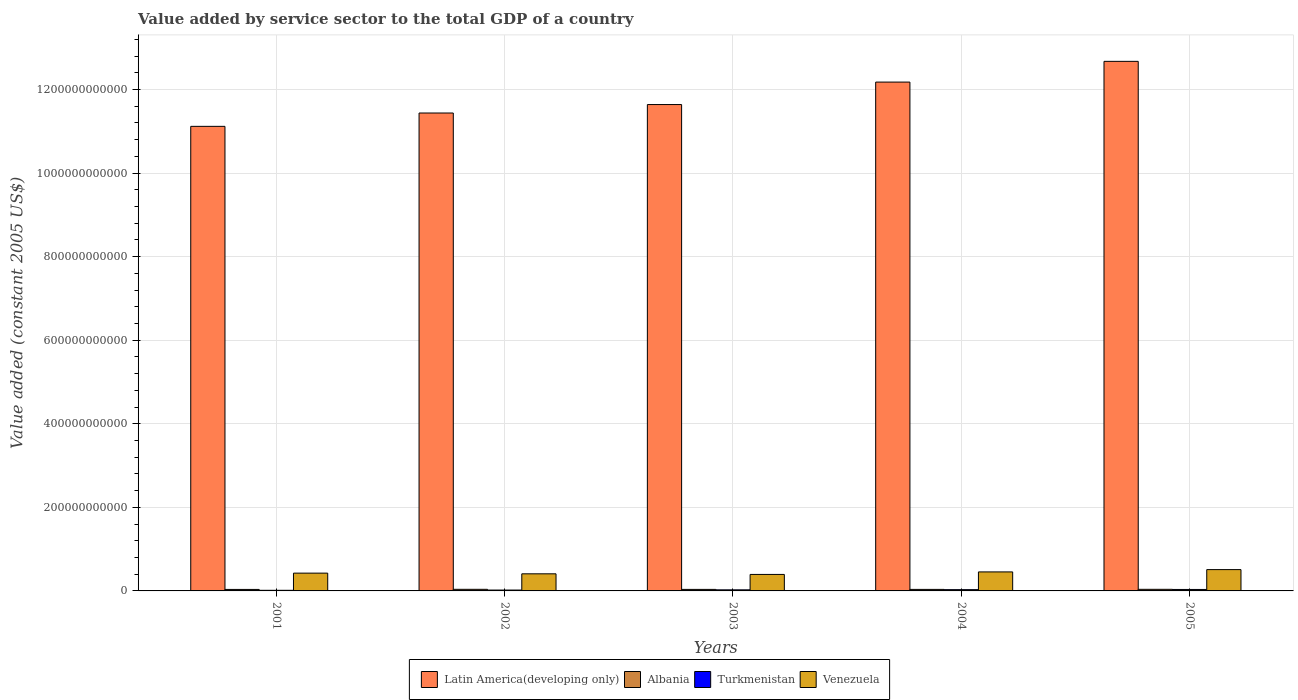How many different coloured bars are there?
Ensure brevity in your answer.  4. How many groups of bars are there?
Offer a very short reply. 5. How many bars are there on the 5th tick from the right?
Your response must be concise. 4. What is the label of the 5th group of bars from the left?
Your answer should be very brief. 2005. What is the value added by service sector in Venezuela in 2004?
Your answer should be very brief. 4.55e+1. Across all years, what is the maximum value added by service sector in Turkmenistan?
Your response must be concise. 3.48e+09. Across all years, what is the minimum value added by service sector in Turkmenistan?
Your response must be concise. 1.47e+09. In which year was the value added by service sector in Latin America(developing only) maximum?
Your response must be concise. 2005. In which year was the value added by service sector in Turkmenistan minimum?
Give a very brief answer. 2001. What is the total value added by service sector in Latin America(developing only) in the graph?
Provide a short and direct response. 5.91e+12. What is the difference between the value added by service sector in Turkmenistan in 2003 and that in 2005?
Your answer should be very brief. -8.97e+08. What is the difference between the value added by service sector in Albania in 2005 and the value added by service sector in Latin America(developing only) in 2001?
Keep it short and to the point. -1.11e+12. What is the average value added by service sector in Latin America(developing only) per year?
Offer a terse response. 1.18e+12. In the year 2004, what is the difference between the value added by service sector in Turkmenistan and value added by service sector in Latin America(developing only)?
Ensure brevity in your answer.  -1.21e+12. What is the ratio of the value added by service sector in Albania in 2001 to that in 2005?
Make the answer very short. 0.94. Is the value added by service sector in Latin America(developing only) in 2001 less than that in 2005?
Your answer should be very brief. Yes. What is the difference between the highest and the second highest value added by service sector in Albania?
Your response must be concise. 7.24e+05. What is the difference between the highest and the lowest value added by service sector in Albania?
Ensure brevity in your answer.  2.42e+08. In how many years, is the value added by service sector in Venezuela greater than the average value added by service sector in Venezuela taken over all years?
Keep it short and to the point. 2. Is it the case that in every year, the sum of the value added by service sector in Turkmenistan and value added by service sector in Venezuela is greater than the sum of value added by service sector in Latin America(developing only) and value added by service sector in Albania?
Your response must be concise. No. What does the 4th bar from the left in 2005 represents?
Ensure brevity in your answer.  Venezuela. What does the 4th bar from the right in 2005 represents?
Make the answer very short. Latin America(developing only). Is it the case that in every year, the sum of the value added by service sector in Latin America(developing only) and value added by service sector in Albania is greater than the value added by service sector in Venezuela?
Make the answer very short. Yes. How many bars are there?
Provide a succinct answer. 20. How many years are there in the graph?
Ensure brevity in your answer.  5. What is the difference between two consecutive major ticks on the Y-axis?
Your response must be concise. 2.00e+11. Are the values on the major ticks of Y-axis written in scientific E-notation?
Keep it short and to the point. No. Does the graph contain any zero values?
Offer a very short reply. No. Where does the legend appear in the graph?
Offer a very short reply. Bottom center. How many legend labels are there?
Provide a short and direct response. 4. What is the title of the graph?
Give a very brief answer. Value added by service sector to the total GDP of a country. What is the label or title of the X-axis?
Give a very brief answer. Years. What is the label or title of the Y-axis?
Give a very brief answer. Value added (constant 2005 US$). What is the Value added (constant 2005 US$) of Latin America(developing only) in 2001?
Keep it short and to the point. 1.11e+12. What is the Value added (constant 2005 US$) in Albania in 2001?
Ensure brevity in your answer.  3.59e+09. What is the Value added (constant 2005 US$) in Turkmenistan in 2001?
Give a very brief answer. 1.47e+09. What is the Value added (constant 2005 US$) in Venezuela in 2001?
Your response must be concise. 4.26e+1. What is the Value added (constant 2005 US$) of Latin America(developing only) in 2002?
Provide a short and direct response. 1.14e+12. What is the Value added (constant 2005 US$) in Albania in 2002?
Your answer should be very brief. 3.83e+09. What is the Value added (constant 2005 US$) in Turkmenistan in 2002?
Your response must be concise. 2.07e+09. What is the Value added (constant 2005 US$) of Venezuela in 2002?
Give a very brief answer. 4.09e+1. What is the Value added (constant 2005 US$) in Latin America(developing only) in 2003?
Make the answer very short. 1.16e+12. What is the Value added (constant 2005 US$) in Albania in 2003?
Ensure brevity in your answer.  3.63e+09. What is the Value added (constant 2005 US$) in Turkmenistan in 2003?
Your answer should be very brief. 2.58e+09. What is the Value added (constant 2005 US$) of Venezuela in 2003?
Your response must be concise. 3.95e+1. What is the Value added (constant 2005 US$) of Latin America(developing only) in 2004?
Offer a terse response. 1.22e+12. What is the Value added (constant 2005 US$) of Albania in 2004?
Provide a short and direct response. 3.64e+09. What is the Value added (constant 2005 US$) in Turkmenistan in 2004?
Make the answer very short. 3.06e+09. What is the Value added (constant 2005 US$) of Venezuela in 2004?
Ensure brevity in your answer.  4.55e+1. What is the Value added (constant 2005 US$) of Latin America(developing only) in 2005?
Provide a succinct answer. 1.27e+12. What is the Value added (constant 2005 US$) of Albania in 2005?
Offer a terse response. 3.83e+09. What is the Value added (constant 2005 US$) in Turkmenistan in 2005?
Your answer should be very brief. 3.48e+09. What is the Value added (constant 2005 US$) in Venezuela in 2005?
Offer a terse response. 5.10e+1. Across all years, what is the maximum Value added (constant 2005 US$) in Latin America(developing only)?
Your response must be concise. 1.27e+12. Across all years, what is the maximum Value added (constant 2005 US$) in Albania?
Give a very brief answer. 3.83e+09. Across all years, what is the maximum Value added (constant 2005 US$) of Turkmenistan?
Offer a very short reply. 3.48e+09. Across all years, what is the maximum Value added (constant 2005 US$) of Venezuela?
Provide a succinct answer. 5.10e+1. Across all years, what is the minimum Value added (constant 2005 US$) of Latin America(developing only)?
Your response must be concise. 1.11e+12. Across all years, what is the minimum Value added (constant 2005 US$) in Albania?
Give a very brief answer. 3.59e+09. Across all years, what is the minimum Value added (constant 2005 US$) of Turkmenistan?
Make the answer very short. 1.47e+09. Across all years, what is the minimum Value added (constant 2005 US$) of Venezuela?
Provide a short and direct response. 3.95e+1. What is the total Value added (constant 2005 US$) in Latin America(developing only) in the graph?
Provide a short and direct response. 5.91e+12. What is the total Value added (constant 2005 US$) in Albania in the graph?
Provide a short and direct response. 1.85e+1. What is the total Value added (constant 2005 US$) of Turkmenistan in the graph?
Your answer should be very brief. 1.27e+1. What is the total Value added (constant 2005 US$) of Venezuela in the graph?
Your answer should be very brief. 2.19e+11. What is the difference between the Value added (constant 2005 US$) of Latin America(developing only) in 2001 and that in 2002?
Give a very brief answer. -3.20e+1. What is the difference between the Value added (constant 2005 US$) of Albania in 2001 and that in 2002?
Keep it short and to the point. -2.42e+08. What is the difference between the Value added (constant 2005 US$) of Turkmenistan in 2001 and that in 2002?
Your answer should be compact. -5.93e+08. What is the difference between the Value added (constant 2005 US$) of Venezuela in 2001 and that in 2002?
Give a very brief answer. 1.62e+09. What is the difference between the Value added (constant 2005 US$) in Latin America(developing only) in 2001 and that in 2003?
Your response must be concise. -5.22e+1. What is the difference between the Value added (constant 2005 US$) of Albania in 2001 and that in 2003?
Your answer should be very brief. -4.42e+07. What is the difference between the Value added (constant 2005 US$) of Turkmenistan in 2001 and that in 2003?
Offer a very short reply. -1.11e+09. What is the difference between the Value added (constant 2005 US$) of Venezuela in 2001 and that in 2003?
Your response must be concise. 3.09e+09. What is the difference between the Value added (constant 2005 US$) of Latin America(developing only) in 2001 and that in 2004?
Provide a short and direct response. -1.06e+11. What is the difference between the Value added (constant 2005 US$) of Albania in 2001 and that in 2004?
Offer a very short reply. -5.27e+07. What is the difference between the Value added (constant 2005 US$) of Turkmenistan in 2001 and that in 2004?
Your response must be concise. -1.59e+09. What is the difference between the Value added (constant 2005 US$) in Venezuela in 2001 and that in 2004?
Keep it short and to the point. -2.91e+09. What is the difference between the Value added (constant 2005 US$) in Latin America(developing only) in 2001 and that in 2005?
Provide a short and direct response. -1.56e+11. What is the difference between the Value added (constant 2005 US$) in Albania in 2001 and that in 2005?
Offer a very short reply. -2.42e+08. What is the difference between the Value added (constant 2005 US$) in Turkmenistan in 2001 and that in 2005?
Your answer should be very brief. -2.00e+09. What is the difference between the Value added (constant 2005 US$) of Venezuela in 2001 and that in 2005?
Provide a short and direct response. -8.47e+09. What is the difference between the Value added (constant 2005 US$) in Latin America(developing only) in 2002 and that in 2003?
Provide a short and direct response. -2.02e+1. What is the difference between the Value added (constant 2005 US$) of Albania in 2002 and that in 2003?
Keep it short and to the point. 1.98e+08. What is the difference between the Value added (constant 2005 US$) of Turkmenistan in 2002 and that in 2003?
Give a very brief answer. -5.15e+08. What is the difference between the Value added (constant 2005 US$) of Venezuela in 2002 and that in 2003?
Offer a very short reply. 1.47e+09. What is the difference between the Value added (constant 2005 US$) in Latin America(developing only) in 2002 and that in 2004?
Your answer should be very brief. -7.40e+1. What is the difference between the Value added (constant 2005 US$) in Albania in 2002 and that in 2004?
Provide a short and direct response. 1.90e+08. What is the difference between the Value added (constant 2005 US$) of Turkmenistan in 2002 and that in 2004?
Provide a short and direct response. -9.95e+08. What is the difference between the Value added (constant 2005 US$) in Venezuela in 2002 and that in 2004?
Offer a very short reply. -4.54e+09. What is the difference between the Value added (constant 2005 US$) of Latin America(developing only) in 2002 and that in 2005?
Make the answer very short. -1.24e+11. What is the difference between the Value added (constant 2005 US$) of Albania in 2002 and that in 2005?
Your answer should be very brief. 7.24e+05. What is the difference between the Value added (constant 2005 US$) in Turkmenistan in 2002 and that in 2005?
Offer a terse response. -1.41e+09. What is the difference between the Value added (constant 2005 US$) of Venezuela in 2002 and that in 2005?
Give a very brief answer. -1.01e+1. What is the difference between the Value added (constant 2005 US$) of Latin America(developing only) in 2003 and that in 2004?
Make the answer very short. -5.37e+1. What is the difference between the Value added (constant 2005 US$) in Albania in 2003 and that in 2004?
Ensure brevity in your answer.  -8.49e+06. What is the difference between the Value added (constant 2005 US$) in Turkmenistan in 2003 and that in 2004?
Your response must be concise. -4.80e+08. What is the difference between the Value added (constant 2005 US$) of Venezuela in 2003 and that in 2004?
Keep it short and to the point. -6.01e+09. What is the difference between the Value added (constant 2005 US$) of Latin America(developing only) in 2003 and that in 2005?
Make the answer very short. -1.03e+11. What is the difference between the Value added (constant 2005 US$) in Albania in 2003 and that in 2005?
Ensure brevity in your answer.  -1.97e+08. What is the difference between the Value added (constant 2005 US$) of Turkmenistan in 2003 and that in 2005?
Your response must be concise. -8.97e+08. What is the difference between the Value added (constant 2005 US$) of Venezuela in 2003 and that in 2005?
Ensure brevity in your answer.  -1.16e+1. What is the difference between the Value added (constant 2005 US$) in Latin America(developing only) in 2004 and that in 2005?
Make the answer very short. -4.96e+1. What is the difference between the Value added (constant 2005 US$) of Albania in 2004 and that in 2005?
Offer a terse response. -1.89e+08. What is the difference between the Value added (constant 2005 US$) of Turkmenistan in 2004 and that in 2005?
Offer a terse response. -4.17e+08. What is the difference between the Value added (constant 2005 US$) in Venezuela in 2004 and that in 2005?
Your response must be concise. -5.56e+09. What is the difference between the Value added (constant 2005 US$) of Latin America(developing only) in 2001 and the Value added (constant 2005 US$) of Albania in 2002?
Your answer should be very brief. 1.11e+12. What is the difference between the Value added (constant 2005 US$) in Latin America(developing only) in 2001 and the Value added (constant 2005 US$) in Turkmenistan in 2002?
Your answer should be compact. 1.11e+12. What is the difference between the Value added (constant 2005 US$) of Latin America(developing only) in 2001 and the Value added (constant 2005 US$) of Venezuela in 2002?
Provide a short and direct response. 1.07e+12. What is the difference between the Value added (constant 2005 US$) in Albania in 2001 and the Value added (constant 2005 US$) in Turkmenistan in 2002?
Offer a very short reply. 1.52e+09. What is the difference between the Value added (constant 2005 US$) in Albania in 2001 and the Value added (constant 2005 US$) in Venezuela in 2002?
Make the answer very short. -3.74e+1. What is the difference between the Value added (constant 2005 US$) in Turkmenistan in 2001 and the Value added (constant 2005 US$) in Venezuela in 2002?
Offer a terse response. -3.95e+1. What is the difference between the Value added (constant 2005 US$) in Latin America(developing only) in 2001 and the Value added (constant 2005 US$) in Albania in 2003?
Give a very brief answer. 1.11e+12. What is the difference between the Value added (constant 2005 US$) in Latin America(developing only) in 2001 and the Value added (constant 2005 US$) in Turkmenistan in 2003?
Provide a short and direct response. 1.11e+12. What is the difference between the Value added (constant 2005 US$) in Latin America(developing only) in 2001 and the Value added (constant 2005 US$) in Venezuela in 2003?
Provide a short and direct response. 1.07e+12. What is the difference between the Value added (constant 2005 US$) of Albania in 2001 and the Value added (constant 2005 US$) of Turkmenistan in 2003?
Provide a short and direct response. 1.00e+09. What is the difference between the Value added (constant 2005 US$) of Albania in 2001 and the Value added (constant 2005 US$) of Venezuela in 2003?
Keep it short and to the point. -3.59e+1. What is the difference between the Value added (constant 2005 US$) of Turkmenistan in 2001 and the Value added (constant 2005 US$) of Venezuela in 2003?
Make the answer very short. -3.80e+1. What is the difference between the Value added (constant 2005 US$) of Latin America(developing only) in 2001 and the Value added (constant 2005 US$) of Albania in 2004?
Ensure brevity in your answer.  1.11e+12. What is the difference between the Value added (constant 2005 US$) of Latin America(developing only) in 2001 and the Value added (constant 2005 US$) of Turkmenistan in 2004?
Keep it short and to the point. 1.11e+12. What is the difference between the Value added (constant 2005 US$) of Latin America(developing only) in 2001 and the Value added (constant 2005 US$) of Venezuela in 2004?
Your response must be concise. 1.07e+12. What is the difference between the Value added (constant 2005 US$) in Albania in 2001 and the Value added (constant 2005 US$) in Turkmenistan in 2004?
Offer a very short reply. 5.24e+08. What is the difference between the Value added (constant 2005 US$) of Albania in 2001 and the Value added (constant 2005 US$) of Venezuela in 2004?
Offer a terse response. -4.19e+1. What is the difference between the Value added (constant 2005 US$) of Turkmenistan in 2001 and the Value added (constant 2005 US$) of Venezuela in 2004?
Your answer should be very brief. -4.40e+1. What is the difference between the Value added (constant 2005 US$) of Latin America(developing only) in 2001 and the Value added (constant 2005 US$) of Albania in 2005?
Offer a terse response. 1.11e+12. What is the difference between the Value added (constant 2005 US$) of Latin America(developing only) in 2001 and the Value added (constant 2005 US$) of Turkmenistan in 2005?
Your answer should be compact. 1.11e+12. What is the difference between the Value added (constant 2005 US$) of Latin America(developing only) in 2001 and the Value added (constant 2005 US$) of Venezuela in 2005?
Provide a succinct answer. 1.06e+12. What is the difference between the Value added (constant 2005 US$) in Albania in 2001 and the Value added (constant 2005 US$) in Turkmenistan in 2005?
Provide a succinct answer. 1.08e+08. What is the difference between the Value added (constant 2005 US$) of Albania in 2001 and the Value added (constant 2005 US$) of Venezuela in 2005?
Offer a very short reply. -4.74e+1. What is the difference between the Value added (constant 2005 US$) of Turkmenistan in 2001 and the Value added (constant 2005 US$) of Venezuela in 2005?
Your answer should be very brief. -4.96e+1. What is the difference between the Value added (constant 2005 US$) of Latin America(developing only) in 2002 and the Value added (constant 2005 US$) of Albania in 2003?
Ensure brevity in your answer.  1.14e+12. What is the difference between the Value added (constant 2005 US$) of Latin America(developing only) in 2002 and the Value added (constant 2005 US$) of Turkmenistan in 2003?
Keep it short and to the point. 1.14e+12. What is the difference between the Value added (constant 2005 US$) in Latin America(developing only) in 2002 and the Value added (constant 2005 US$) in Venezuela in 2003?
Provide a succinct answer. 1.10e+12. What is the difference between the Value added (constant 2005 US$) in Albania in 2002 and the Value added (constant 2005 US$) in Turkmenistan in 2003?
Offer a very short reply. 1.25e+09. What is the difference between the Value added (constant 2005 US$) in Albania in 2002 and the Value added (constant 2005 US$) in Venezuela in 2003?
Offer a very short reply. -3.56e+1. What is the difference between the Value added (constant 2005 US$) in Turkmenistan in 2002 and the Value added (constant 2005 US$) in Venezuela in 2003?
Provide a short and direct response. -3.74e+1. What is the difference between the Value added (constant 2005 US$) of Latin America(developing only) in 2002 and the Value added (constant 2005 US$) of Albania in 2004?
Your response must be concise. 1.14e+12. What is the difference between the Value added (constant 2005 US$) of Latin America(developing only) in 2002 and the Value added (constant 2005 US$) of Turkmenistan in 2004?
Your response must be concise. 1.14e+12. What is the difference between the Value added (constant 2005 US$) of Latin America(developing only) in 2002 and the Value added (constant 2005 US$) of Venezuela in 2004?
Offer a terse response. 1.10e+12. What is the difference between the Value added (constant 2005 US$) in Albania in 2002 and the Value added (constant 2005 US$) in Turkmenistan in 2004?
Provide a succinct answer. 7.67e+08. What is the difference between the Value added (constant 2005 US$) in Albania in 2002 and the Value added (constant 2005 US$) in Venezuela in 2004?
Offer a terse response. -4.16e+1. What is the difference between the Value added (constant 2005 US$) of Turkmenistan in 2002 and the Value added (constant 2005 US$) of Venezuela in 2004?
Your response must be concise. -4.34e+1. What is the difference between the Value added (constant 2005 US$) in Latin America(developing only) in 2002 and the Value added (constant 2005 US$) in Albania in 2005?
Ensure brevity in your answer.  1.14e+12. What is the difference between the Value added (constant 2005 US$) in Latin America(developing only) in 2002 and the Value added (constant 2005 US$) in Turkmenistan in 2005?
Ensure brevity in your answer.  1.14e+12. What is the difference between the Value added (constant 2005 US$) of Latin America(developing only) in 2002 and the Value added (constant 2005 US$) of Venezuela in 2005?
Your answer should be very brief. 1.09e+12. What is the difference between the Value added (constant 2005 US$) of Albania in 2002 and the Value added (constant 2005 US$) of Turkmenistan in 2005?
Offer a very short reply. 3.50e+08. What is the difference between the Value added (constant 2005 US$) of Albania in 2002 and the Value added (constant 2005 US$) of Venezuela in 2005?
Provide a succinct answer. -4.72e+1. What is the difference between the Value added (constant 2005 US$) in Turkmenistan in 2002 and the Value added (constant 2005 US$) in Venezuela in 2005?
Provide a short and direct response. -4.90e+1. What is the difference between the Value added (constant 2005 US$) of Latin America(developing only) in 2003 and the Value added (constant 2005 US$) of Albania in 2004?
Your answer should be compact. 1.16e+12. What is the difference between the Value added (constant 2005 US$) in Latin America(developing only) in 2003 and the Value added (constant 2005 US$) in Turkmenistan in 2004?
Offer a terse response. 1.16e+12. What is the difference between the Value added (constant 2005 US$) in Latin America(developing only) in 2003 and the Value added (constant 2005 US$) in Venezuela in 2004?
Your response must be concise. 1.12e+12. What is the difference between the Value added (constant 2005 US$) of Albania in 2003 and the Value added (constant 2005 US$) of Turkmenistan in 2004?
Your answer should be compact. 5.69e+08. What is the difference between the Value added (constant 2005 US$) in Albania in 2003 and the Value added (constant 2005 US$) in Venezuela in 2004?
Give a very brief answer. -4.18e+1. What is the difference between the Value added (constant 2005 US$) in Turkmenistan in 2003 and the Value added (constant 2005 US$) in Venezuela in 2004?
Make the answer very short. -4.29e+1. What is the difference between the Value added (constant 2005 US$) of Latin America(developing only) in 2003 and the Value added (constant 2005 US$) of Albania in 2005?
Offer a very short reply. 1.16e+12. What is the difference between the Value added (constant 2005 US$) in Latin America(developing only) in 2003 and the Value added (constant 2005 US$) in Turkmenistan in 2005?
Your answer should be compact. 1.16e+12. What is the difference between the Value added (constant 2005 US$) of Latin America(developing only) in 2003 and the Value added (constant 2005 US$) of Venezuela in 2005?
Offer a very short reply. 1.11e+12. What is the difference between the Value added (constant 2005 US$) in Albania in 2003 and the Value added (constant 2005 US$) in Turkmenistan in 2005?
Your response must be concise. 1.52e+08. What is the difference between the Value added (constant 2005 US$) of Albania in 2003 and the Value added (constant 2005 US$) of Venezuela in 2005?
Provide a succinct answer. -4.74e+1. What is the difference between the Value added (constant 2005 US$) of Turkmenistan in 2003 and the Value added (constant 2005 US$) of Venezuela in 2005?
Offer a very short reply. -4.84e+1. What is the difference between the Value added (constant 2005 US$) in Latin America(developing only) in 2004 and the Value added (constant 2005 US$) in Albania in 2005?
Your response must be concise. 1.21e+12. What is the difference between the Value added (constant 2005 US$) of Latin America(developing only) in 2004 and the Value added (constant 2005 US$) of Turkmenistan in 2005?
Make the answer very short. 1.21e+12. What is the difference between the Value added (constant 2005 US$) of Latin America(developing only) in 2004 and the Value added (constant 2005 US$) of Venezuela in 2005?
Offer a very short reply. 1.17e+12. What is the difference between the Value added (constant 2005 US$) of Albania in 2004 and the Value added (constant 2005 US$) of Turkmenistan in 2005?
Give a very brief answer. 1.60e+08. What is the difference between the Value added (constant 2005 US$) of Albania in 2004 and the Value added (constant 2005 US$) of Venezuela in 2005?
Your answer should be very brief. -4.74e+1. What is the difference between the Value added (constant 2005 US$) of Turkmenistan in 2004 and the Value added (constant 2005 US$) of Venezuela in 2005?
Provide a short and direct response. -4.80e+1. What is the average Value added (constant 2005 US$) of Latin America(developing only) per year?
Provide a succinct answer. 1.18e+12. What is the average Value added (constant 2005 US$) of Albania per year?
Make the answer very short. 3.70e+09. What is the average Value added (constant 2005 US$) in Turkmenistan per year?
Ensure brevity in your answer.  2.53e+09. What is the average Value added (constant 2005 US$) in Venezuela per year?
Give a very brief answer. 4.39e+1. In the year 2001, what is the difference between the Value added (constant 2005 US$) in Latin America(developing only) and Value added (constant 2005 US$) in Albania?
Keep it short and to the point. 1.11e+12. In the year 2001, what is the difference between the Value added (constant 2005 US$) of Latin America(developing only) and Value added (constant 2005 US$) of Turkmenistan?
Offer a very short reply. 1.11e+12. In the year 2001, what is the difference between the Value added (constant 2005 US$) in Latin America(developing only) and Value added (constant 2005 US$) in Venezuela?
Keep it short and to the point. 1.07e+12. In the year 2001, what is the difference between the Value added (constant 2005 US$) in Albania and Value added (constant 2005 US$) in Turkmenistan?
Offer a terse response. 2.11e+09. In the year 2001, what is the difference between the Value added (constant 2005 US$) in Albania and Value added (constant 2005 US$) in Venezuela?
Offer a very short reply. -3.90e+1. In the year 2001, what is the difference between the Value added (constant 2005 US$) in Turkmenistan and Value added (constant 2005 US$) in Venezuela?
Provide a succinct answer. -4.11e+1. In the year 2002, what is the difference between the Value added (constant 2005 US$) in Latin America(developing only) and Value added (constant 2005 US$) in Albania?
Keep it short and to the point. 1.14e+12. In the year 2002, what is the difference between the Value added (constant 2005 US$) in Latin America(developing only) and Value added (constant 2005 US$) in Turkmenistan?
Offer a terse response. 1.14e+12. In the year 2002, what is the difference between the Value added (constant 2005 US$) in Latin America(developing only) and Value added (constant 2005 US$) in Venezuela?
Make the answer very short. 1.10e+12. In the year 2002, what is the difference between the Value added (constant 2005 US$) of Albania and Value added (constant 2005 US$) of Turkmenistan?
Keep it short and to the point. 1.76e+09. In the year 2002, what is the difference between the Value added (constant 2005 US$) of Albania and Value added (constant 2005 US$) of Venezuela?
Ensure brevity in your answer.  -3.71e+1. In the year 2002, what is the difference between the Value added (constant 2005 US$) of Turkmenistan and Value added (constant 2005 US$) of Venezuela?
Keep it short and to the point. -3.89e+1. In the year 2003, what is the difference between the Value added (constant 2005 US$) in Latin America(developing only) and Value added (constant 2005 US$) in Albania?
Your answer should be very brief. 1.16e+12. In the year 2003, what is the difference between the Value added (constant 2005 US$) in Latin America(developing only) and Value added (constant 2005 US$) in Turkmenistan?
Provide a succinct answer. 1.16e+12. In the year 2003, what is the difference between the Value added (constant 2005 US$) of Latin America(developing only) and Value added (constant 2005 US$) of Venezuela?
Offer a very short reply. 1.12e+12. In the year 2003, what is the difference between the Value added (constant 2005 US$) of Albania and Value added (constant 2005 US$) of Turkmenistan?
Your answer should be very brief. 1.05e+09. In the year 2003, what is the difference between the Value added (constant 2005 US$) of Albania and Value added (constant 2005 US$) of Venezuela?
Offer a terse response. -3.58e+1. In the year 2003, what is the difference between the Value added (constant 2005 US$) of Turkmenistan and Value added (constant 2005 US$) of Venezuela?
Offer a very short reply. -3.69e+1. In the year 2004, what is the difference between the Value added (constant 2005 US$) in Latin America(developing only) and Value added (constant 2005 US$) in Albania?
Your response must be concise. 1.21e+12. In the year 2004, what is the difference between the Value added (constant 2005 US$) of Latin America(developing only) and Value added (constant 2005 US$) of Turkmenistan?
Ensure brevity in your answer.  1.21e+12. In the year 2004, what is the difference between the Value added (constant 2005 US$) of Latin America(developing only) and Value added (constant 2005 US$) of Venezuela?
Ensure brevity in your answer.  1.17e+12. In the year 2004, what is the difference between the Value added (constant 2005 US$) of Albania and Value added (constant 2005 US$) of Turkmenistan?
Offer a very short reply. 5.77e+08. In the year 2004, what is the difference between the Value added (constant 2005 US$) in Albania and Value added (constant 2005 US$) in Venezuela?
Give a very brief answer. -4.18e+1. In the year 2004, what is the difference between the Value added (constant 2005 US$) of Turkmenistan and Value added (constant 2005 US$) of Venezuela?
Offer a terse response. -4.24e+1. In the year 2005, what is the difference between the Value added (constant 2005 US$) of Latin America(developing only) and Value added (constant 2005 US$) of Albania?
Offer a very short reply. 1.26e+12. In the year 2005, what is the difference between the Value added (constant 2005 US$) of Latin America(developing only) and Value added (constant 2005 US$) of Turkmenistan?
Keep it short and to the point. 1.26e+12. In the year 2005, what is the difference between the Value added (constant 2005 US$) of Latin America(developing only) and Value added (constant 2005 US$) of Venezuela?
Keep it short and to the point. 1.22e+12. In the year 2005, what is the difference between the Value added (constant 2005 US$) in Albania and Value added (constant 2005 US$) in Turkmenistan?
Offer a terse response. 3.49e+08. In the year 2005, what is the difference between the Value added (constant 2005 US$) of Albania and Value added (constant 2005 US$) of Venezuela?
Make the answer very short. -4.72e+1. In the year 2005, what is the difference between the Value added (constant 2005 US$) in Turkmenistan and Value added (constant 2005 US$) in Venezuela?
Offer a terse response. -4.76e+1. What is the ratio of the Value added (constant 2005 US$) of Latin America(developing only) in 2001 to that in 2002?
Give a very brief answer. 0.97. What is the ratio of the Value added (constant 2005 US$) of Albania in 2001 to that in 2002?
Keep it short and to the point. 0.94. What is the ratio of the Value added (constant 2005 US$) in Turkmenistan in 2001 to that in 2002?
Ensure brevity in your answer.  0.71. What is the ratio of the Value added (constant 2005 US$) in Venezuela in 2001 to that in 2002?
Make the answer very short. 1.04. What is the ratio of the Value added (constant 2005 US$) of Latin America(developing only) in 2001 to that in 2003?
Give a very brief answer. 0.96. What is the ratio of the Value added (constant 2005 US$) of Turkmenistan in 2001 to that in 2003?
Ensure brevity in your answer.  0.57. What is the ratio of the Value added (constant 2005 US$) in Venezuela in 2001 to that in 2003?
Offer a terse response. 1.08. What is the ratio of the Value added (constant 2005 US$) in Latin America(developing only) in 2001 to that in 2004?
Make the answer very short. 0.91. What is the ratio of the Value added (constant 2005 US$) of Albania in 2001 to that in 2004?
Offer a very short reply. 0.99. What is the ratio of the Value added (constant 2005 US$) in Turkmenistan in 2001 to that in 2004?
Your response must be concise. 0.48. What is the ratio of the Value added (constant 2005 US$) of Venezuela in 2001 to that in 2004?
Your answer should be compact. 0.94. What is the ratio of the Value added (constant 2005 US$) of Latin America(developing only) in 2001 to that in 2005?
Provide a succinct answer. 0.88. What is the ratio of the Value added (constant 2005 US$) in Albania in 2001 to that in 2005?
Your answer should be very brief. 0.94. What is the ratio of the Value added (constant 2005 US$) of Turkmenistan in 2001 to that in 2005?
Keep it short and to the point. 0.42. What is the ratio of the Value added (constant 2005 US$) in Venezuela in 2001 to that in 2005?
Provide a short and direct response. 0.83. What is the ratio of the Value added (constant 2005 US$) of Latin America(developing only) in 2002 to that in 2003?
Keep it short and to the point. 0.98. What is the ratio of the Value added (constant 2005 US$) of Albania in 2002 to that in 2003?
Your answer should be compact. 1.05. What is the ratio of the Value added (constant 2005 US$) of Turkmenistan in 2002 to that in 2003?
Provide a short and direct response. 0.8. What is the ratio of the Value added (constant 2005 US$) of Venezuela in 2002 to that in 2003?
Your answer should be compact. 1.04. What is the ratio of the Value added (constant 2005 US$) in Latin America(developing only) in 2002 to that in 2004?
Offer a very short reply. 0.94. What is the ratio of the Value added (constant 2005 US$) of Albania in 2002 to that in 2004?
Your answer should be very brief. 1.05. What is the ratio of the Value added (constant 2005 US$) in Turkmenistan in 2002 to that in 2004?
Offer a very short reply. 0.68. What is the ratio of the Value added (constant 2005 US$) in Venezuela in 2002 to that in 2004?
Give a very brief answer. 0.9. What is the ratio of the Value added (constant 2005 US$) in Latin America(developing only) in 2002 to that in 2005?
Offer a terse response. 0.9. What is the ratio of the Value added (constant 2005 US$) in Albania in 2002 to that in 2005?
Your answer should be compact. 1. What is the ratio of the Value added (constant 2005 US$) in Turkmenistan in 2002 to that in 2005?
Give a very brief answer. 0.59. What is the ratio of the Value added (constant 2005 US$) of Venezuela in 2002 to that in 2005?
Your answer should be compact. 0.8. What is the ratio of the Value added (constant 2005 US$) in Latin America(developing only) in 2003 to that in 2004?
Provide a short and direct response. 0.96. What is the ratio of the Value added (constant 2005 US$) of Turkmenistan in 2003 to that in 2004?
Provide a succinct answer. 0.84. What is the ratio of the Value added (constant 2005 US$) of Venezuela in 2003 to that in 2004?
Give a very brief answer. 0.87. What is the ratio of the Value added (constant 2005 US$) of Latin America(developing only) in 2003 to that in 2005?
Offer a very short reply. 0.92. What is the ratio of the Value added (constant 2005 US$) of Albania in 2003 to that in 2005?
Ensure brevity in your answer.  0.95. What is the ratio of the Value added (constant 2005 US$) in Turkmenistan in 2003 to that in 2005?
Offer a very short reply. 0.74. What is the ratio of the Value added (constant 2005 US$) of Venezuela in 2003 to that in 2005?
Provide a succinct answer. 0.77. What is the ratio of the Value added (constant 2005 US$) of Latin America(developing only) in 2004 to that in 2005?
Your answer should be compact. 0.96. What is the ratio of the Value added (constant 2005 US$) of Albania in 2004 to that in 2005?
Provide a short and direct response. 0.95. What is the ratio of the Value added (constant 2005 US$) in Turkmenistan in 2004 to that in 2005?
Give a very brief answer. 0.88. What is the ratio of the Value added (constant 2005 US$) of Venezuela in 2004 to that in 2005?
Keep it short and to the point. 0.89. What is the difference between the highest and the second highest Value added (constant 2005 US$) in Latin America(developing only)?
Keep it short and to the point. 4.96e+1. What is the difference between the highest and the second highest Value added (constant 2005 US$) in Albania?
Your answer should be compact. 7.24e+05. What is the difference between the highest and the second highest Value added (constant 2005 US$) of Turkmenistan?
Keep it short and to the point. 4.17e+08. What is the difference between the highest and the second highest Value added (constant 2005 US$) in Venezuela?
Provide a short and direct response. 5.56e+09. What is the difference between the highest and the lowest Value added (constant 2005 US$) of Latin America(developing only)?
Ensure brevity in your answer.  1.56e+11. What is the difference between the highest and the lowest Value added (constant 2005 US$) of Albania?
Your response must be concise. 2.42e+08. What is the difference between the highest and the lowest Value added (constant 2005 US$) of Turkmenistan?
Provide a succinct answer. 2.00e+09. What is the difference between the highest and the lowest Value added (constant 2005 US$) of Venezuela?
Ensure brevity in your answer.  1.16e+1. 